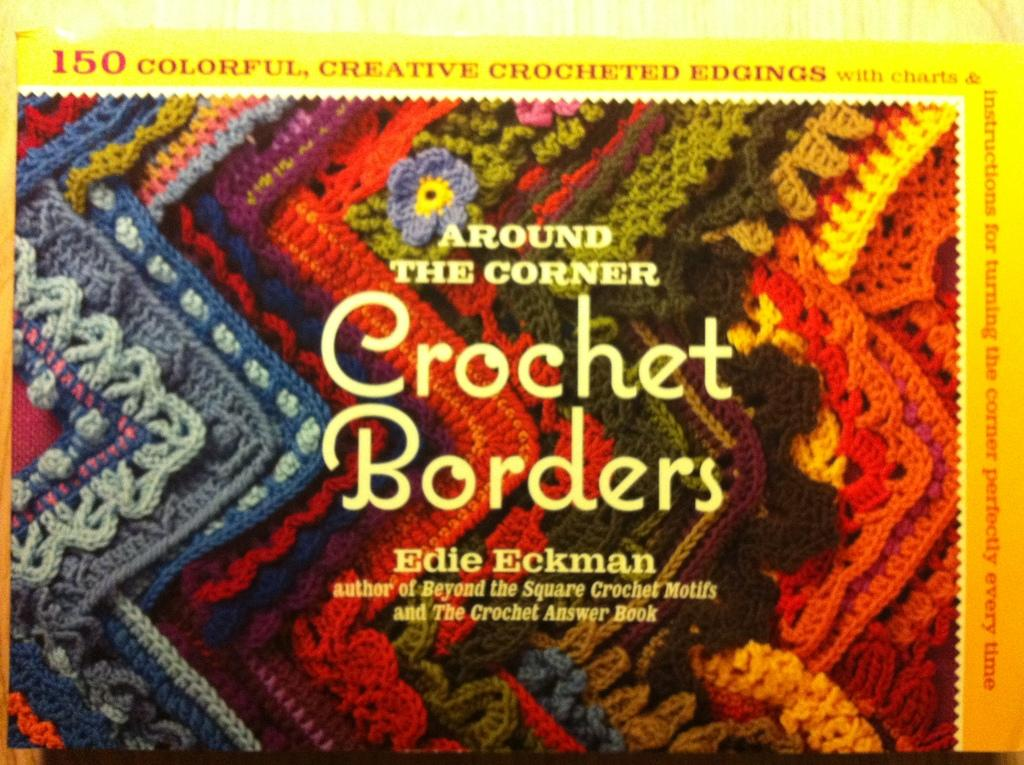<image>
Create a compact narrative representing the image presented. A SEWING BOOK CALLED CROCHET BORDERS BY EDIE ECKMAN 